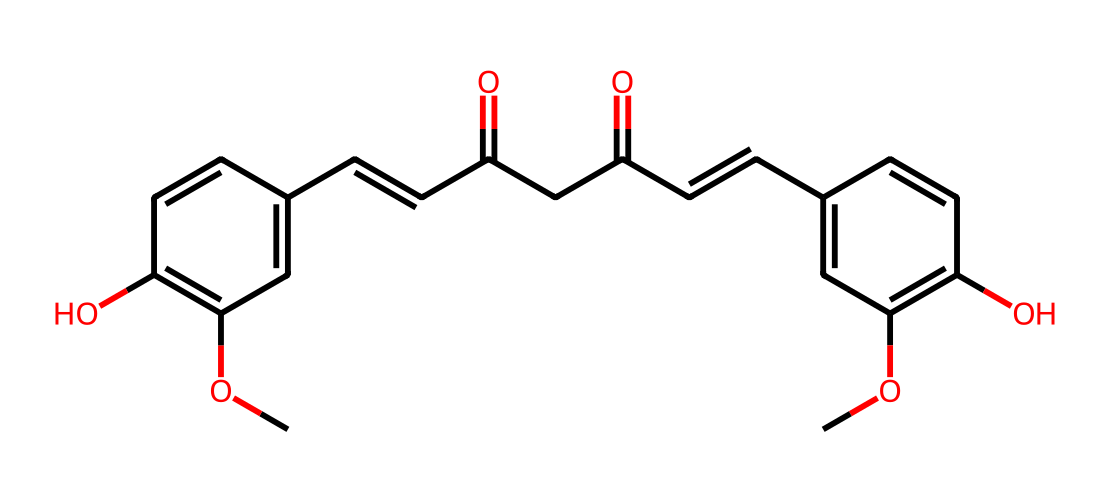What is the total number of carbon atoms in curcumin? By analyzing the SMILES representation, we can count the 'C' characters. In this structure, there are 21 instances of carbon atoms indicated by 'C', as evident in the various segments of the structure.
Answer: 21 How many hydroxyl (–OH) groups are in curcumin? Looking at the chemical structure derived from the SMILES, we can identify the –OH groups represented by 'O' directly followed by 'C' on the ring systems. There are 2 instances of hydroxyl groups in this structure.
Answer: 2 What functional group is primarily responsible for the yellow color of curcumin? The conjugated double bonds and the presence of the diketone (carbonyls) groups in the structure contribute significantly to the color. This is associated specifically with the phenolic and α,β-unsaturated carbonyl functional groups that give the characteristic yellow hue.
Answer: diketone What type of chemical structure is curcumin classified as? Curcumin is classified primarily as a polyphenol, due to its multiple aromatic rings and hydroxyl groups, which are characteristic of polyphenolic compounds. This classification can be inferred from the molecular features represented in the SMILES.
Answer: polyphenol How many rings are present in the structure of curcumin? In examining the SMILES representation, we can identify the cyclical structures indicated by the 'C1' and 'C2' labels in the SMILES, which denote ring closures. In total, there are 2 distinct ring structures in curcumin.
Answer: 2 What is the molecular formula for curcumin? By interpreting the counts of carbon (C), hydrogen (H), and oxygen (O) atoms in the SMILES notation, we can derive the molecular formula C21H20O6, which summarizes the composition of the compound based on the visual data of the chemical structure.
Answer: C21H20O6 